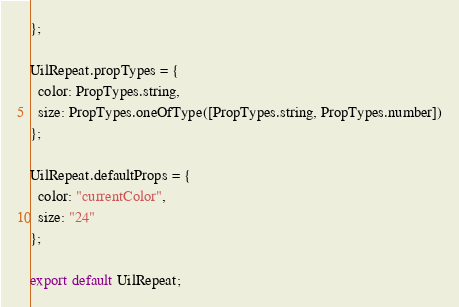<code> <loc_0><loc_0><loc_500><loc_500><_JavaScript_>};

UilRepeat.propTypes = {
  color: PropTypes.string,
  size: PropTypes.oneOfType([PropTypes.string, PropTypes.number])
};

UilRepeat.defaultProps = {
  color: "currentColor",
  size: "24"
};

export default UilRepeat;
</code> 